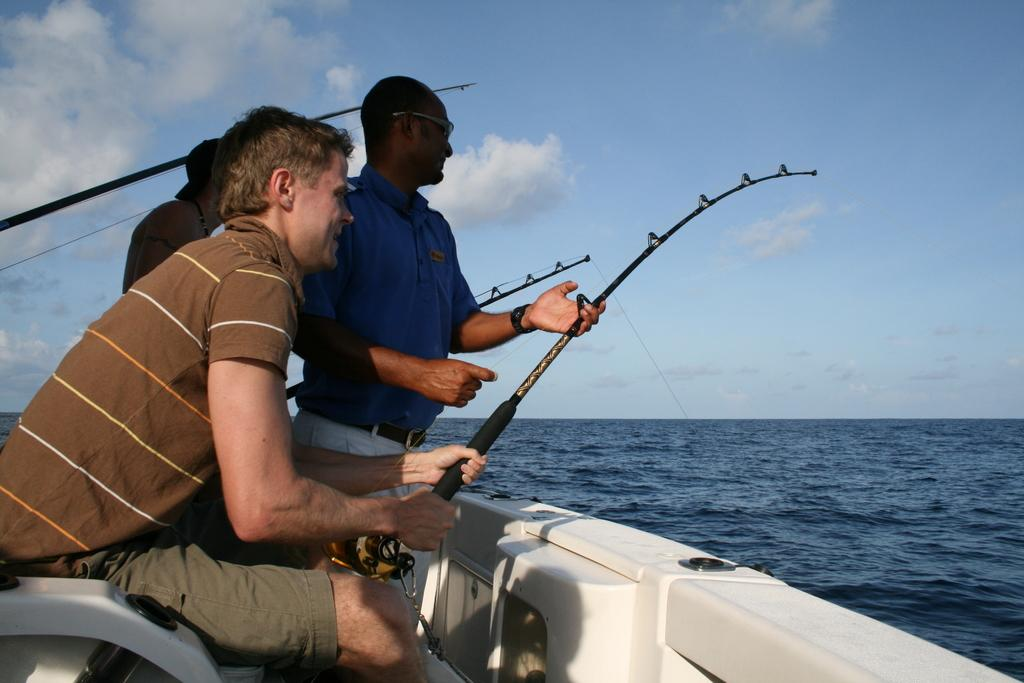What are the people in the image doing? The people in the image are in a boat and holding fishing rods. What can be seen in the background of the image? There is a large water body visible in the image. What is the weather like in the image? The sky is cloudy in the image. What type of credit card is the grandfather using in the image? There is no grandfather or credit card present in the image. How many family members are visible in the image? There is no family member or group of family members present in the image. 